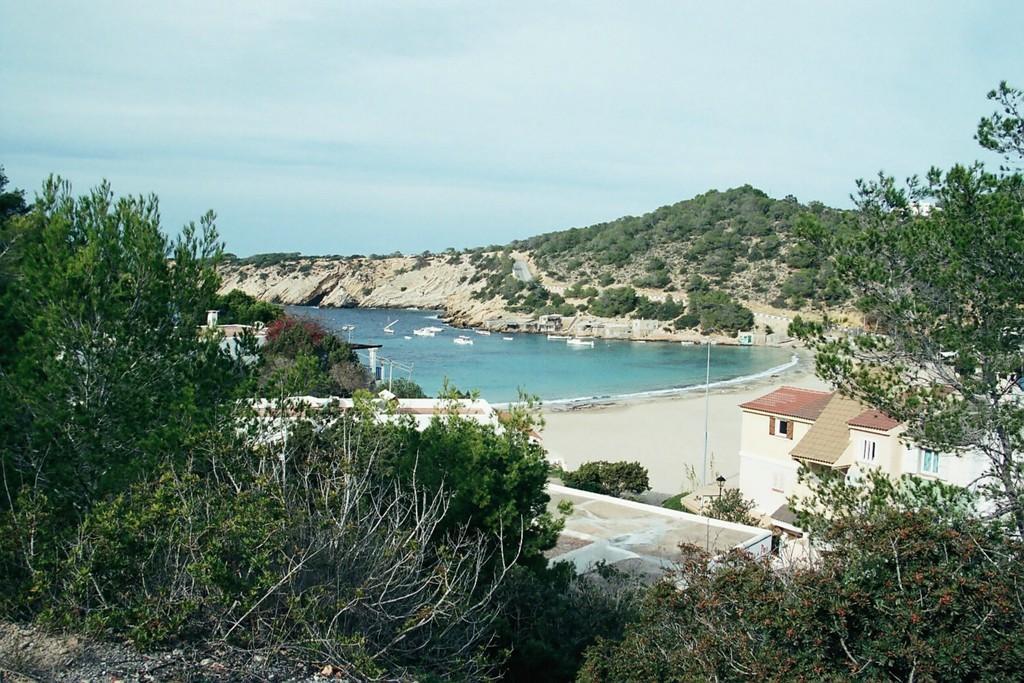How would you summarize this image in a sentence or two? In the image I can see trees, plants, the water, houses, poles and some other objects on the ground. In the background I can see boats on the water and the sky. 